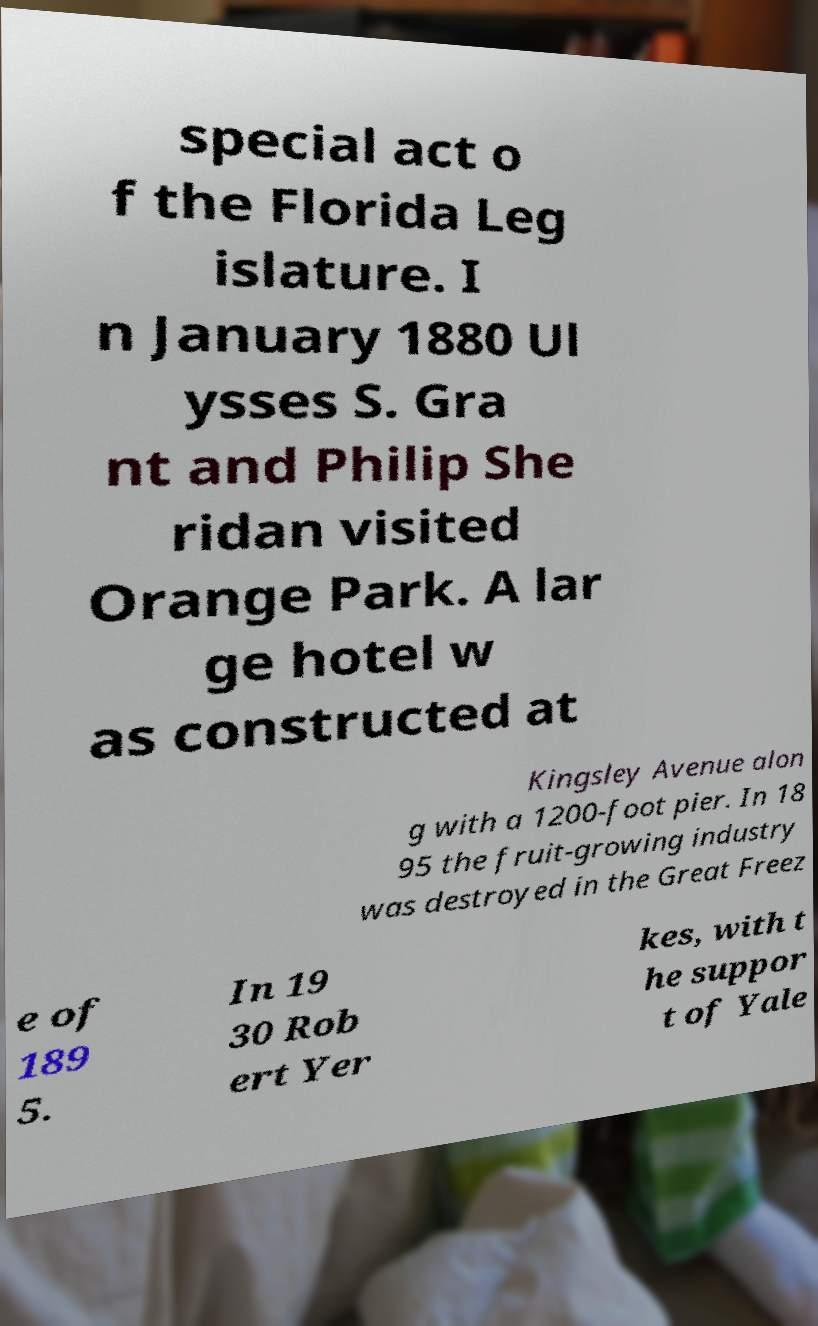Could you extract and type out the text from this image? special act o f the Florida Leg islature. I n January 1880 Ul ysses S. Gra nt and Philip She ridan visited Orange Park. A lar ge hotel w as constructed at Kingsley Avenue alon g with a 1200-foot pier. In 18 95 the fruit-growing industry was destroyed in the Great Freez e of 189 5. In 19 30 Rob ert Yer kes, with t he suppor t of Yale 